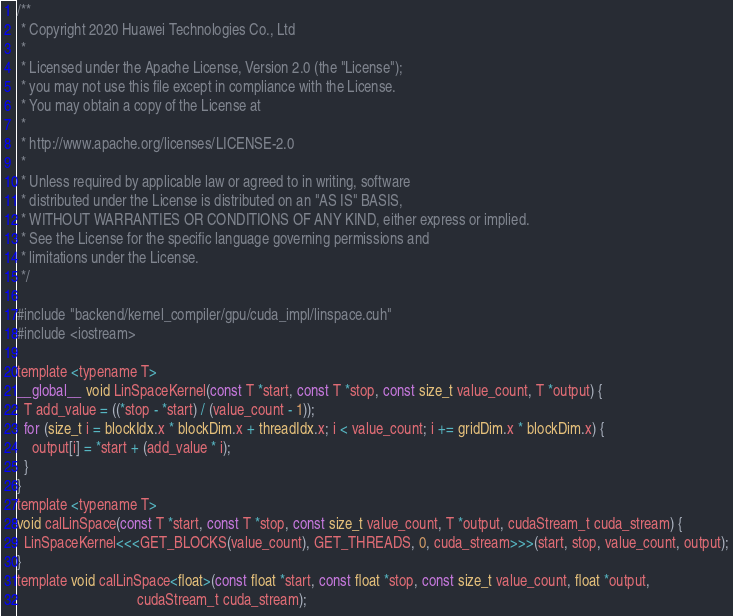<code> <loc_0><loc_0><loc_500><loc_500><_Cuda_>/**
 * Copyright 2020 Huawei Technologies Co., Ltd
 *
 * Licensed under the Apache License, Version 2.0 (the "License");
 * you may not use this file except in compliance with the License.
 * You may obtain a copy of the License at
 *
 * http://www.apache.org/licenses/LICENSE-2.0
 *
 * Unless required by applicable law or agreed to in writing, software
 * distributed under the License is distributed on an "AS IS" BASIS,
 * WITHOUT WARRANTIES OR CONDITIONS OF ANY KIND, either express or implied.
 * See the License for the specific language governing permissions and
 * limitations under the License.
 */

#include "backend/kernel_compiler/gpu/cuda_impl/linspace.cuh"
#include <iostream>

template <typename T>
__global__ void LinSpaceKernel(const T *start, const T *stop, const size_t value_count, T *output) {
  T add_value = ((*stop - *start) / (value_count - 1));
  for (size_t i = blockIdx.x * blockDim.x + threadIdx.x; i < value_count; i += gridDim.x * blockDim.x) {
    output[i] = *start + (add_value * i);
  }
}
template <typename T>
void calLinSpace(const T *start, const T *stop, const size_t value_count, T *output, cudaStream_t cuda_stream) {
  LinSpaceKernel<<<GET_BLOCKS(value_count), GET_THREADS, 0, cuda_stream>>>(start, stop, value_count, output);
}
template void calLinSpace<float>(const float *start, const float *stop, const size_t value_count, float *output,
                                 cudaStream_t cuda_stream);
</code> 